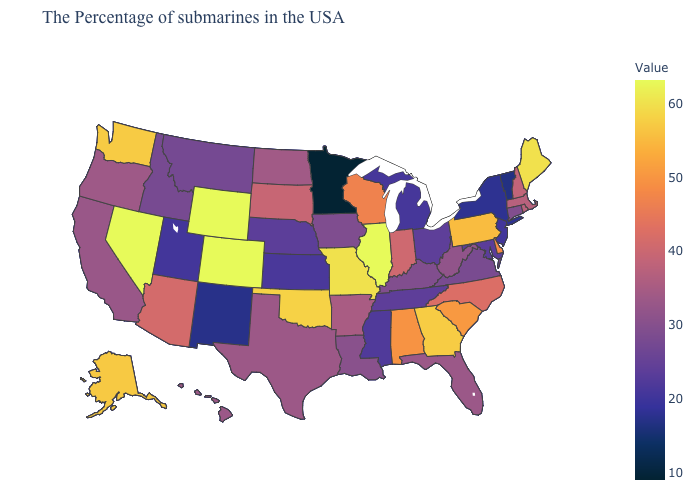Among the states that border North Dakota , which have the highest value?
Answer briefly. South Dakota. Which states have the lowest value in the USA?
Write a very short answer. Minnesota. Does Indiana have the lowest value in the USA?
Answer briefly. No. Does Louisiana have the lowest value in the South?
Concise answer only. No. Among the states that border Utah , does New Mexico have the lowest value?
Give a very brief answer. Yes. Among the states that border New Jersey , does New York have the lowest value?
Give a very brief answer. Yes. 